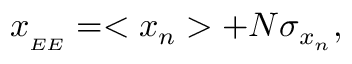Convert formula to latex. <formula><loc_0><loc_0><loc_500><loc_500>\begin{array} { r } { x _ { _ { E E } } = < x _ { n } > + N \sigma _ { x { _ { n } } } , } \end{array}</formula> 